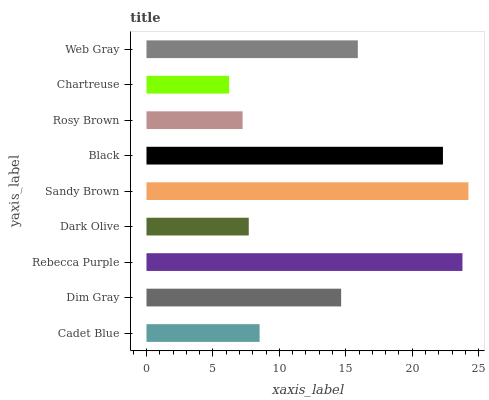Is Chartreuse the minimum?
Answer yes or no. Yes. Is Sandy Brown the maximum?
Answer yes or no. Yes. Is Dim Gray the minimum?
Answer yes or no. No. Is Dim Gray the maximum?
Answer yes or no. No. Is Dim Gray greater than Cadet Blue?
Answer yes or no. Yes. Is Cadet Blue less than Dim Gray?
Answer yes or no. Yes. Is Cadet Blue greater than Dim Gray?
Answer yes or no. No. Is Dim Gray less than Cadet Blue?
Answer yes or no. No. Is Dim Gray the high median?
Answer yes or no. Yes. Is Dim Gray the low median?
Answer yes or no. Yes. Is Dark Olive the high median?
Answer yes or no. No. Is Rosy Brown the low median?
Answer yes or no. No. 